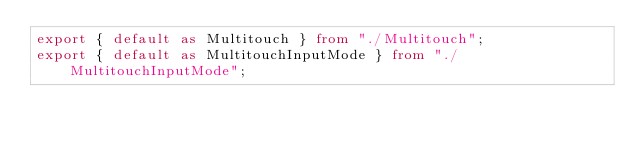<code> <loc_0><loc_0><loc_500><loc_500><_TypeScript_>export { default as Multitouch } from "./Multitouch";
export { default as MultitouchInputMode } from "./MultitouchInputMode";
</code> 